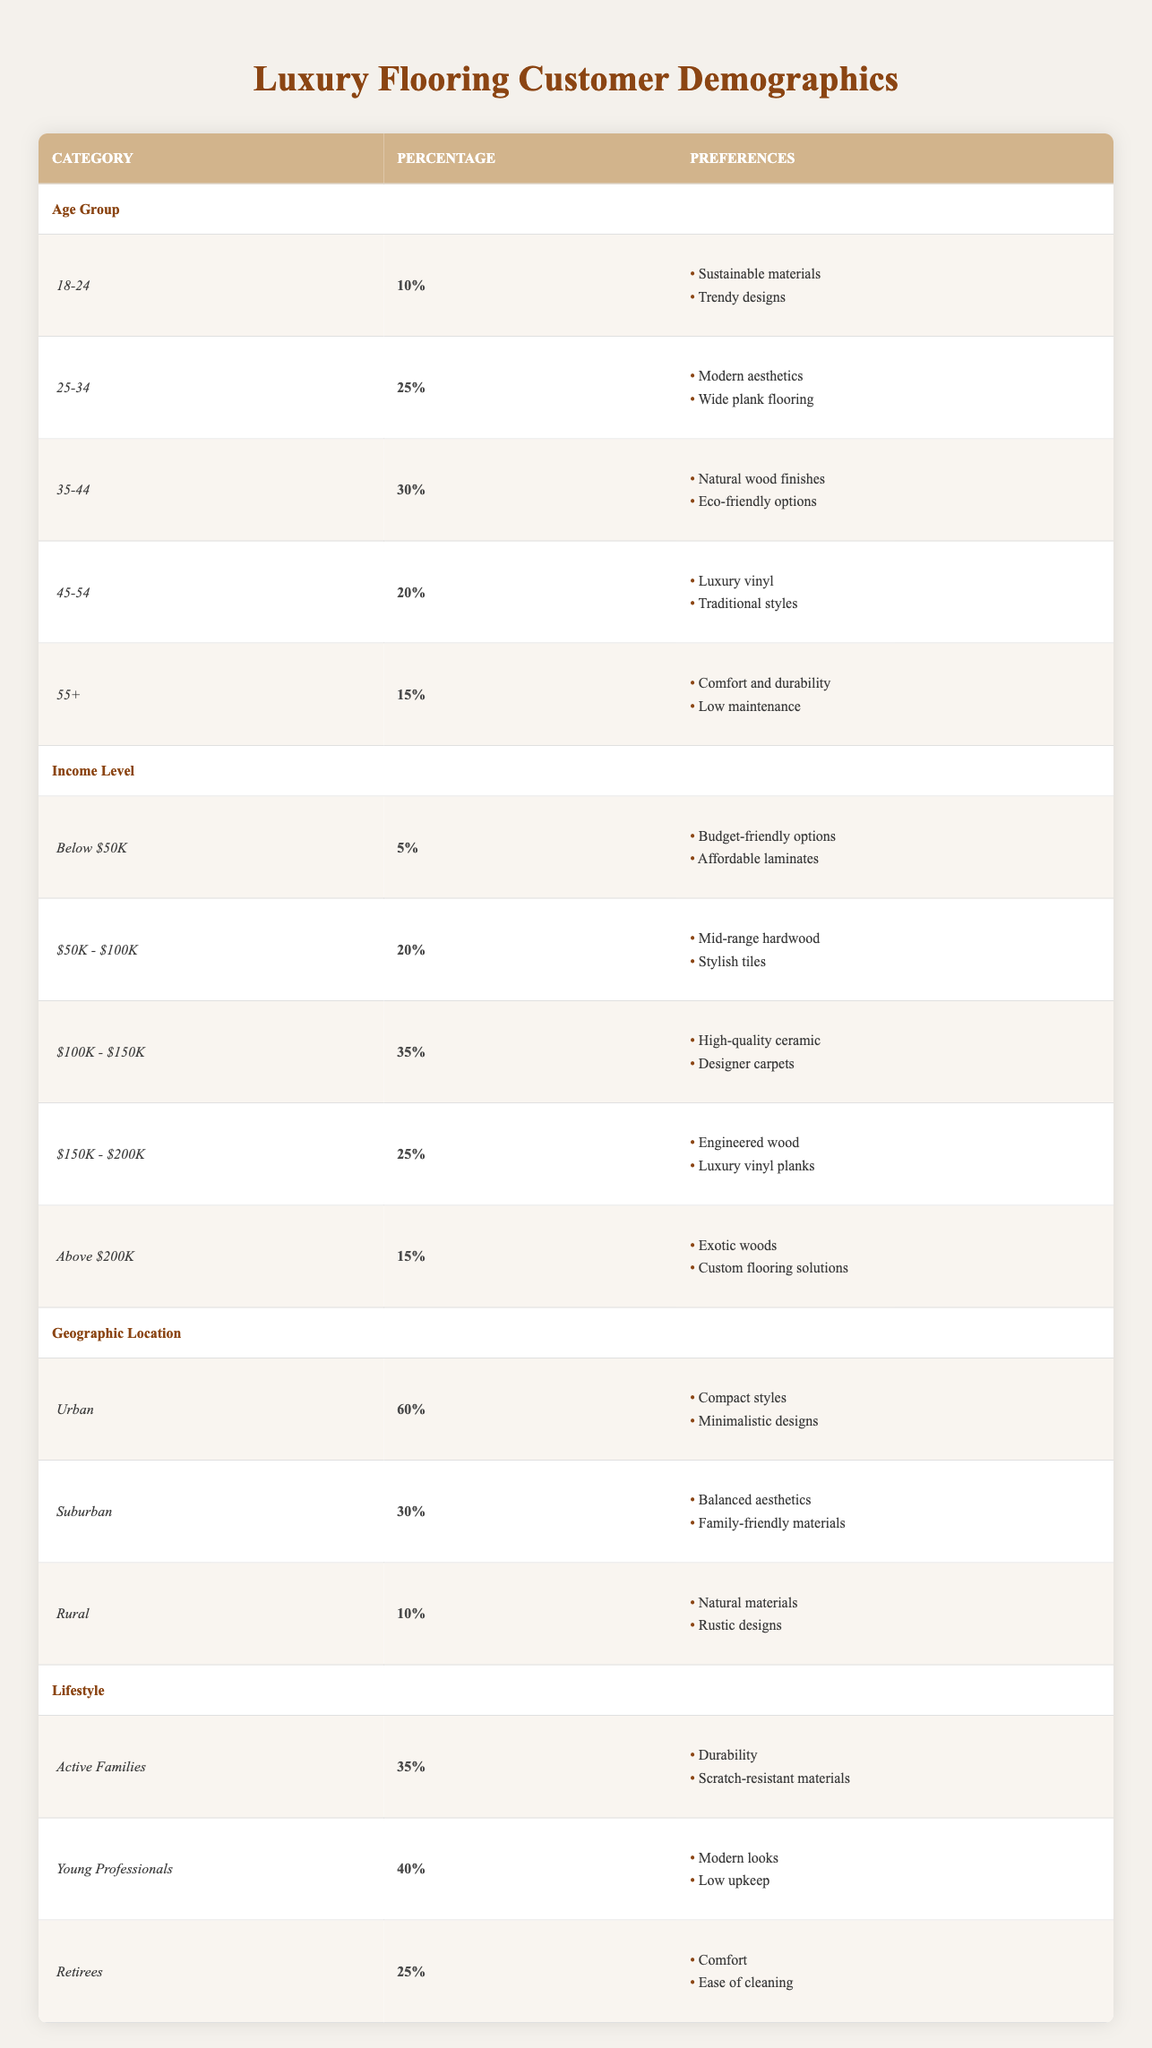What percentage of customers prefer Sustainable materials in the age group 18-24? The table shows that the 18-24 age group has a preference percentage of 10%, which is directly noted in the "Age Group" section.
Answer: 10% What are the top two preferences for customers aged 35-44? The table categorizes the 35-44 age group preferences as "Natural wood finishes" and "Eco-friendly options," providing a clear view of their top two preferences.
Answer: Natural wood finishes, Eco-friendly options Which income level has the highest percentage of customers? By reviewing the "Income Level" section, the category "$100K - $150K" has the highest percentage at 35%, surpassing the other income levels listed.
Answer: $100K - $150K Is it true that 60% of those living in urban areas prefer compact styles? Yes, the table explicitly states that the "Urban" category has a preference of 60% for "Compact styles."
Answer: Yes What is the combined percentage of preferences for the "Urban" and "Rural" categories? The percentage for "Urban" is 60% and for "Rural" is 10%. Adding both gives us a total of 70%, calculated as 60 + 10 = 70.
Answer: 70% What percentage of retirees prefer comfort and ease of cleaning? The "Retirees" lifestyle category indicates a preference percentage of 25% for both "Comfort" and "Ease of cleaning," as shown in the lifestyle section.
Answer: 25% What are the preferences for customers earning above $200K and how does it differ from those earning below $50K? Customers in the "Above $200K" income category prefer "Exotic woods" and "Custom flooring solutions," while those in the "Below $50K" category prefer "Budget-friendly options" and "Affordable laminates." This shows a significant difference in material quality and investment.
Answer: Exotic woods, Custom flooring solutions; Budget-friendly options, Affordable laminates How do preferences for "Active Families" compare to those of "Young Professionals"? "Active Families" prefer "Durability" and "Scratch-resistant materials" with a percentage of 35%, while "Young Professionals" prefer "Modern looks" and "Low upkeep" with a percentage of 40%. Young Professionals have a higher preference percentage by 5%.
Answer: 5% more for Young Professionals Which age group has the least preference for traditional styles, and what is that percentage? The "45-54" age group prefers "Luxury vinyl" and "Traditional styles," showing a preference percentage of 20%. The least preference for traditional styles is thus 20% from this age group.
Answer: 20% 